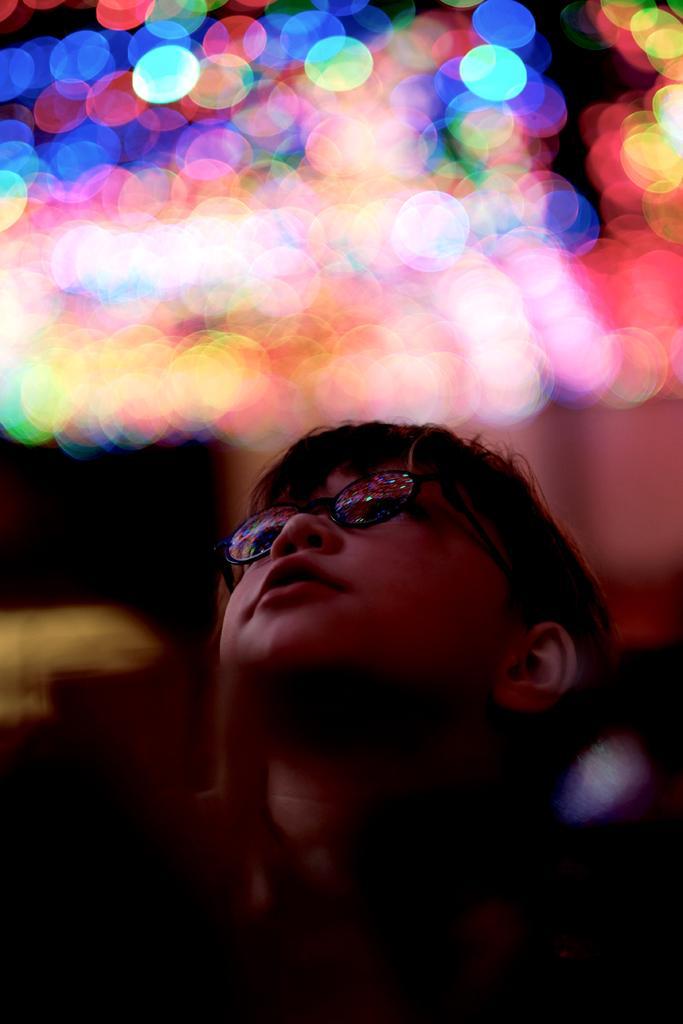Please provide a concise description of this image. In this picture I can see there is a boy standing and in the backdrop I can see there are some lights. 